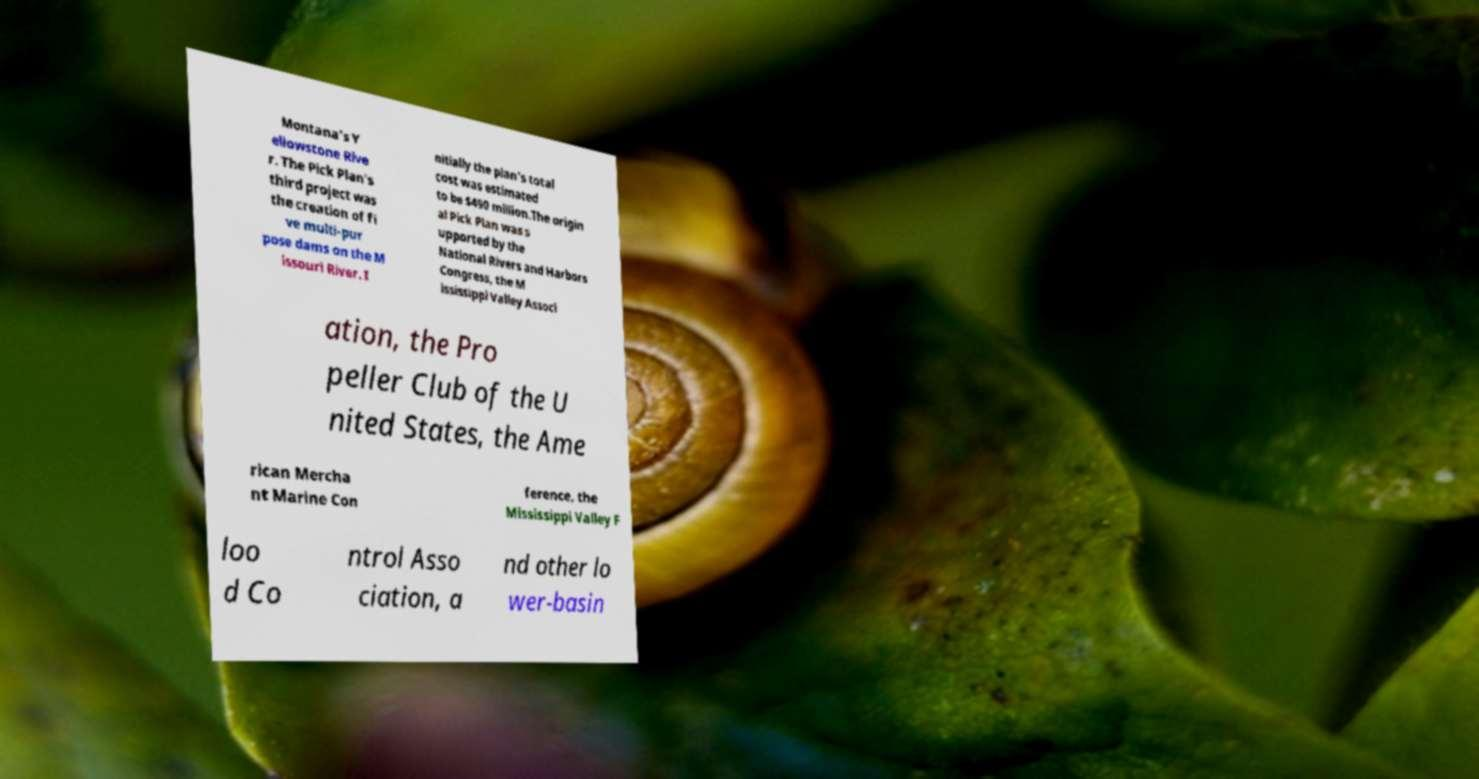There's text embedded in this image that I need extracted. Can you transcribe it verbatim? Montana's Y ellowstone Rive r. The Pick Plan's third project was the creation of fi ve multi-pur pose dams on the M issouri River. I nitially the plan's total cost was estimated to be $490 million.The origin al Pick Plan was s upported by the National Rivers and Harbors Congress, the M ississippi Valley Associ ation, the Pro peller Club of the U nited States, the Ame rican Mercha nt Marine Con ference, the Mississippi Valley F loo d Co ntrol Asso ciation, a nd other lo wer-basin 